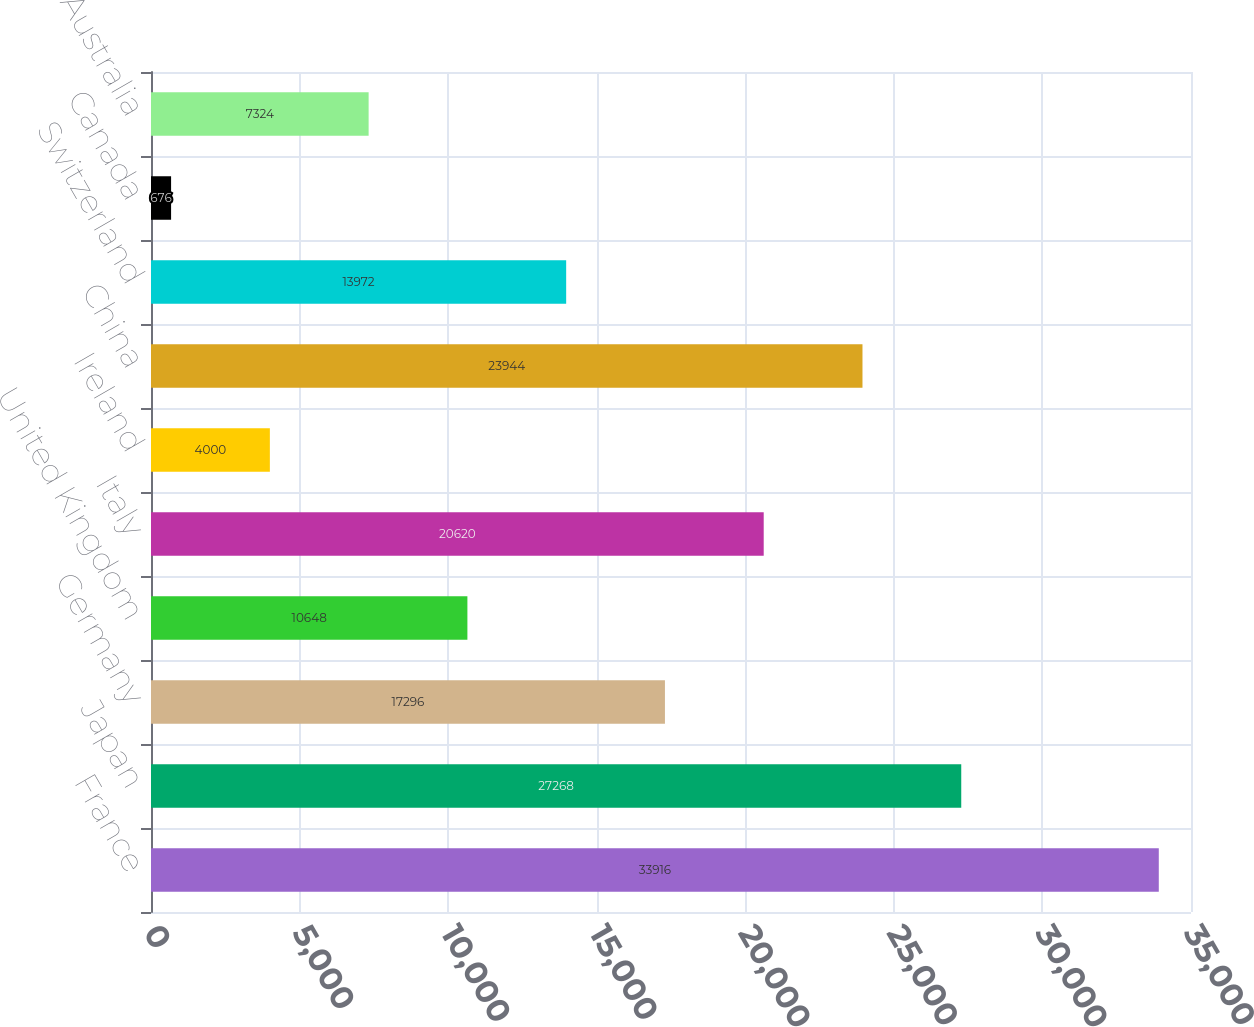Convert chart. <chart><loc_0><loc_0><loc_500><loc_500><bar_chart><fcel>France<fcel>Japan<fcel>Germany<fcel>United Kingdom<fcel>Italy<fcel>Ireland<fcel>China<fcel>Switzerland<fcel>Canada<fcel>Australia<nl><fcel>33916<fcel>27268<fcel>17296<fcel>10648<fcel>20620<fcel>4000<fcel>23944<fcel>13972<fcel>676<fcel>7324<nl></chart> 